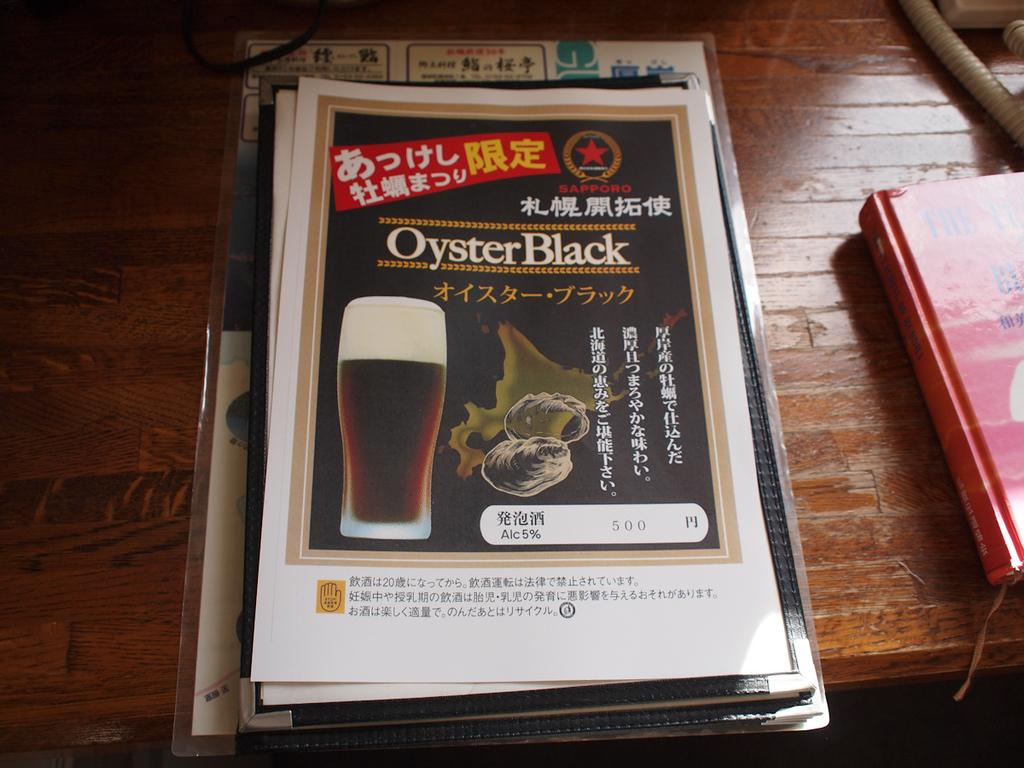Provide a one-sentence caption for the provided image. A menu cover with an image of a beer called Oyster Black. 